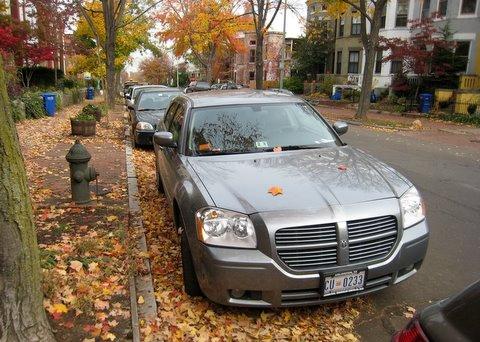From what seasons was this picture taken?
Keep it brief. Fall. Is it trash day?
Keep it brief. Yes. What does the car say?
Concise answer only. Cu 0233. What is the make of the silver vehicle?
Quick response, please. Dodge. 